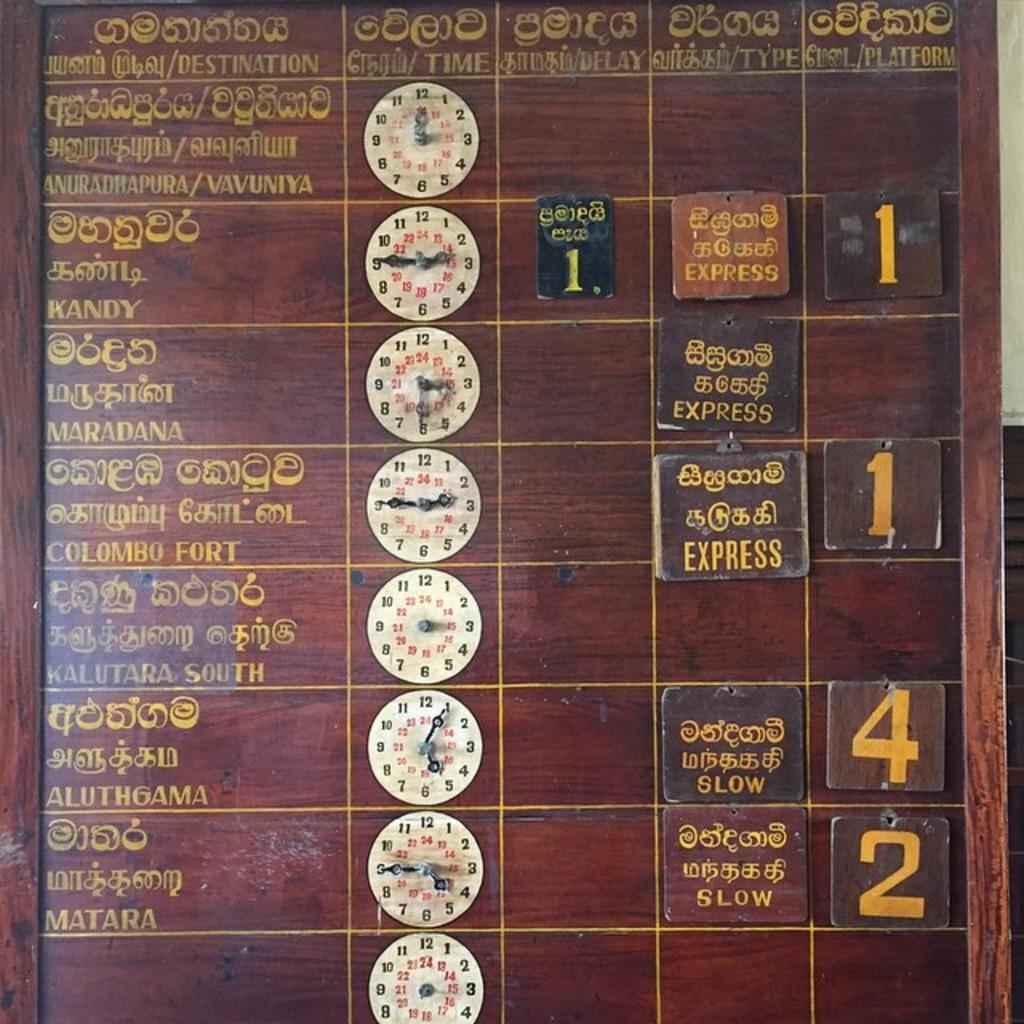Provide a one-sentence caption for the provided image. An arrivals and departures board contains signs for SLOW and EXPRESS. 